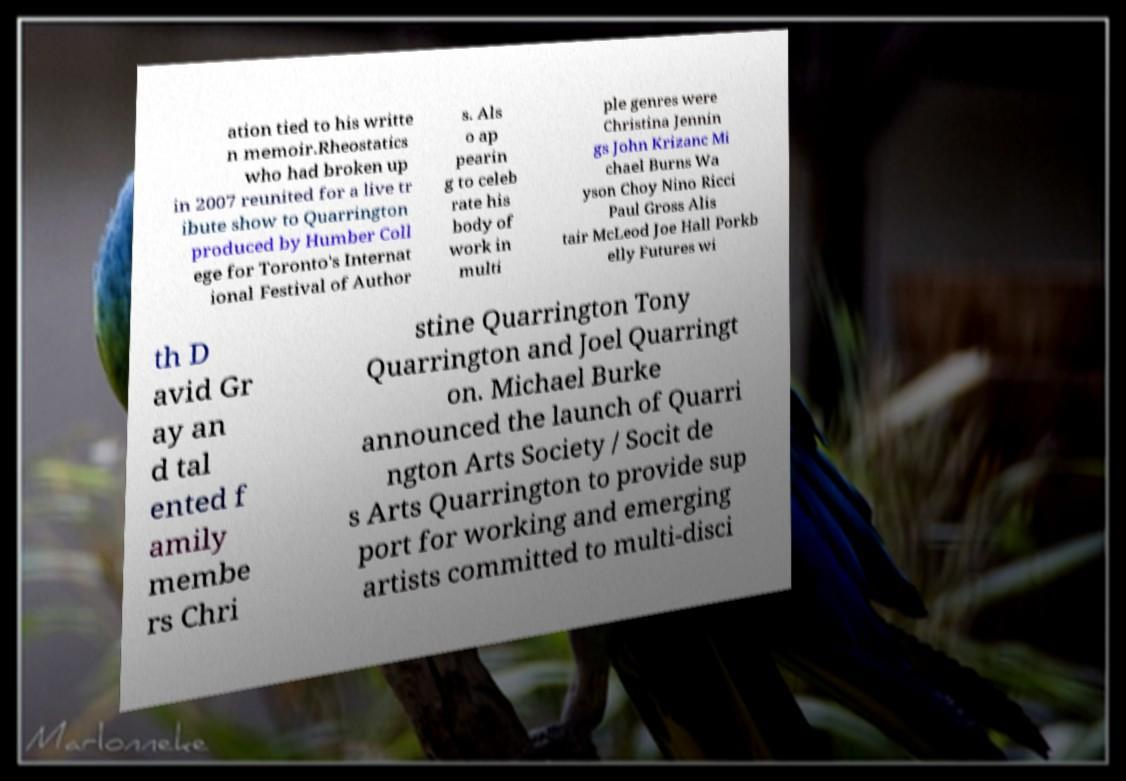Please read and relay the text visible in this image. What does it say? ation tied to his writte n memoir.Rheostatics who had broken up in 2007 reunited for a live tr ibute show to Quarrington produced by Humber Coll ege for Toronto's Internat ional Festival of Author s. Als o ap pearin g to celeb rate his body of work in multi ple genres were Christina Jennin gs John Krizanc Mi chael Burns Wa yson Choy Nino Ricci Paul Gross Alis tair McLeod Joe Hall Porkb elly Futures wi th D avid Gr ay an d tal ented f amily membe rs Chri stine Quarrington Tony Quarrington and Joel Quarringt on. Michael Burke announced the launch of Quarri ngton Arts Society / Socit de s Arts Quarrington to provide sup port for working and emerging artists committed to multi-disci 